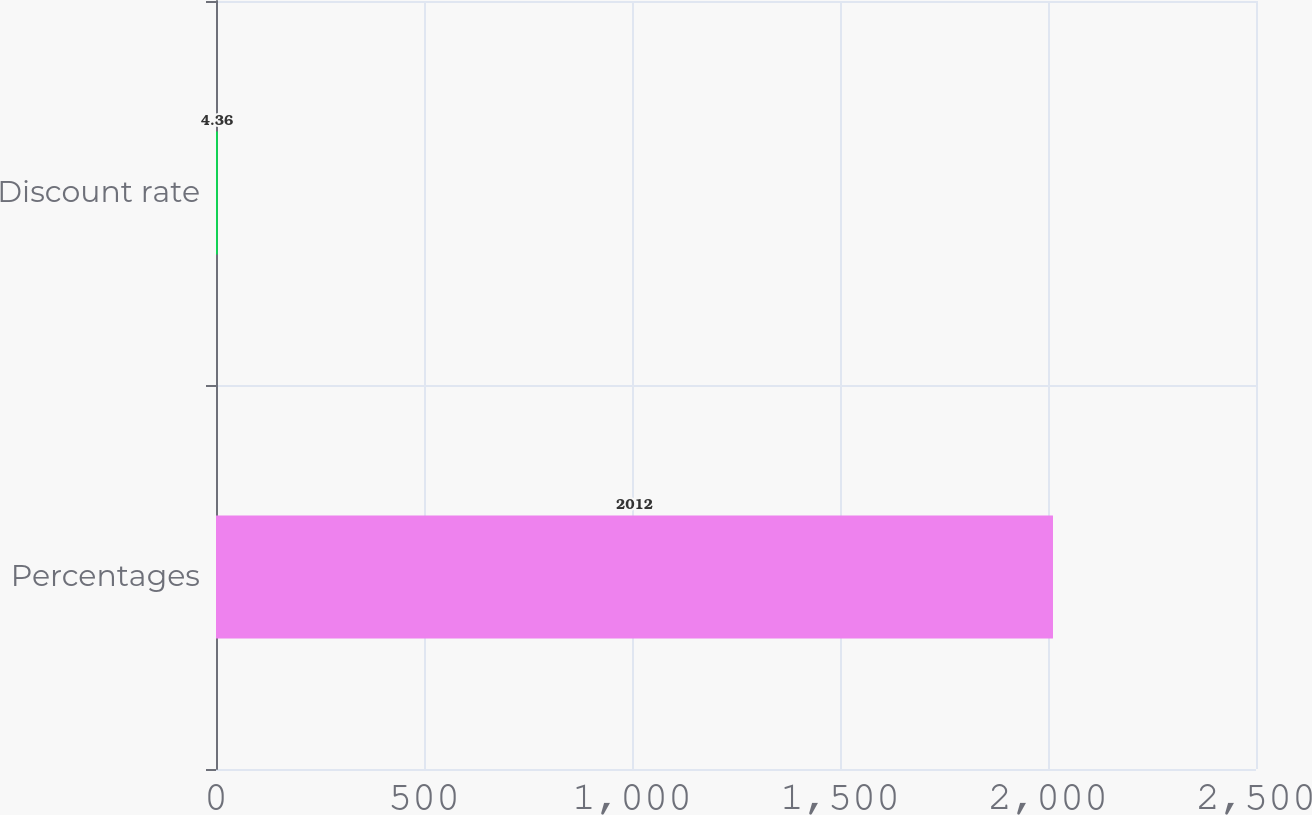<chart> <loc_0><loc_0><loc_500><loc_500><bar_chart><fcel>Percentages<fcel>Discount rate<nl><fcel>2012<fcel>4.36<nl></chart> 